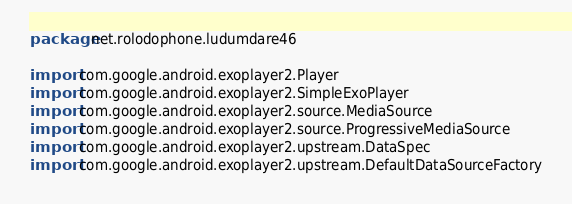Convert code to text. <code><loc_0><loc_0><loc_500><loc_500><_Kotlin_>package net.rolodophone.ludumdare46

import com.google.android.exoplayer2.Player
import com.google.android.exoplayer2.SimpleExoPlayer
import com.google.android.exoplayer2.source.MediaSource
import com.google.android.exoplayer2.source.ProgressiveMediaSource
import com.google.android.exoplayer2.upstream.DataSpec
import com.google.android.exoplayer2.upstream.DefaultDataSourceFactory</code> 